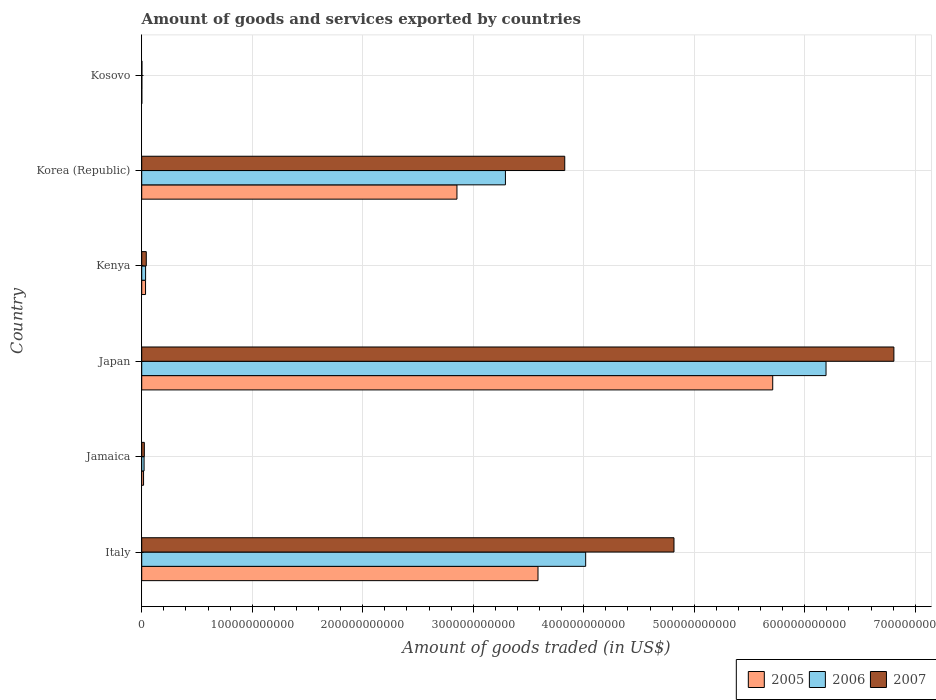How many groups of bars are there?
Give a very brief answer. 6. Are the number of bars on each tick of the Y-axis equal?
Your answer should be very brief. Yes. What is the label of the 1st group of bars from the top?
Ensure brevity in your answer.  Kosovo. In how many cases, is the number of bars for a given country not equal to the number of legend labels?
Provide a succinct answer. 0. What is the total amount of goods and services exported in 2006 in Italy?
Your response must be concise. 4.02e+11. Across all countries, what is the maximum total amount of goods and services exported in 2006?
Your answer should be compact. 6.19e+11. Across all countries, what is the minimum total amount of goods and services exported in 2007?
Give a very brief answer. 1.82e+08. In which country was the total amount of goods and services exported in 2005 minimum?
Offer a very short reply. Kosovo. What is the total total amount of goods and services exported in 2005 in the graph?
Ensure brevity in your answer.  1.22e+12. What is the difference between the total amount of goods and services exported in 2005 in Kenya and that in Korea (Republic)?
Offer a terse response. -2.82e+11. What is the difference between the total amount of goods and services exported in 2007 in Italy and the total amount of goods and services exported in 2006 in Jamaica?
Provide a succinct answer. 4.80e+11. What is the average total amount of goods and services exported in 2007 per country?
Provide a short and direct response. 2.59e+11. What is the difference between the total amount of goods and services exported in 2005 and total amount of goods and services exported in 2007 in Japan?
Your answer should be compact. -1.10e+11. What is the ratio of the total amount of goods and services exported in 2005 in Italy to that in Japan?
Ensure brevity in your answer.  0.63. Is the difference between the total amount of goods and services exported in 2005 in Japan and Korea (Republic) greater than the difference between the total amount of goods and services exported in 2007 in Japan and Korea (Republic)?
Make the answer very short. No. What is the difference between the highest and the second highest total amount of goods and services exported in 2005?
Your answer should be compact. 2.12e+11. What is the difference between the highest and the lowest total amount of goods and services exported in 2007?
Offer a terse response. 6.80e+11. In how many countries, is the total amount of goods and services exported in 2007 greater than the average total amount of goods and services exported in 2007 taken over all countries?
Provide a short and direct response. 3. Is the sum of the total amount of goods and services exported in 2007 in Italy and Japan greater than the maximum total amount of goods and services exported in 2006 across all countries?
Your answer should be very brief. Yes. What does the 1st bar from the top in Kosovo represents?
Make the answer very short. 2007. Is it the case that in every country, the sum of the total amount of goods and services exported in 2007 and total amount of goods and services exported in 2005 is greater than the total amount of goods and services exported in 2006?
Offer a terse response. Yes. How many bars are there?
Your answer should be very brief. 18. Are all the bars in the graph horizontal?
Offer a very short reply. Yes. How many countries are there in the graph?
Give a very brief answer. 6. What is the difference between two consecutive major ticks on the X-axis?
Your answer should be very brief. 1.00e+11. Are the values on the major ticks of X-axis written in scientific E-notation?
Provide a short and direct response. No. Does the graph contain any zero values?
Ensure brevity in your answer.  No. How are the legend labels stacked?
Ensure brevity in your answer.  Horizontal. What is the title of the graph?
Your answer should be compact. Amount of goods and services exported by countries. What is the label or title of the X-axis?
Your response must be concise. Amount of goods traded (in US$). What is the Amount of goods traded (in US$) of 2005 in Italy?
Offer a terse response. 3.59e+11. What is the Amount of goods traded (in US$) of 2006 in Italy?
Provide a succinct answer. 4.02e+11. What is the Amount of goods traded (in US$) in 2007 in Italy?
Make the answer very short. 4.82e+11. What is the Amount of goods traded (in US$) of 2005 in Jamaica?
Ensure brevity in your answer.  1.66e+09. What is the Amount of goods traded (in US$) in 2006 in Jamaica?
Make the answer very short. 2.13e+09. What is the Amount of goods traded (in US$) in 2007 in Jamaica?
Your answer should be compact. 2.36e+09. What is the Amount of goods traded (in US$) in 2005 in Japan?
Provide a succinct answer. 5.71e+11. What is the Amount of goods traded (in US$) of 2006 in Japan?
Offer a very short reply. 6.19e+11. What is the Amount of goods traded (in US$) of 2007 in Japan?
Give a very brief answer. 6.81e+11. What is the Amount of goods traded (in US$) of 2005 in Kenya?
Ensure brevity in your answer.  3.46e+09. What is the Amount of goods traded (in US$) in 2006 in Kenya?
Give a very brief answer. 3.51e+09. What is the Amount of goods traded (in US$) of 2007 in Kenya?
Keep it short and to the point. 4.12e+09. What is the Amount of goods traded (in US$) in 2005 in Korea (Republic)?
Your answer should be very brief. 2.85e+11. What is the Amount of goods traded (in US$) in 2006 in Korea (Republic)?
Your answer should be very brief. 3.29e+11. What is the Amount of goods traded (in US$) of 2007 in Korea (Republic)?
Keep it short and to the point. 3.83e+11. What is the Amount of goods traded (in US$) in 2005 in Kosovo?
Provide a short and direct response. 7.96e+07. What is the Amount of goods traded (in US$) of 2006 in Kosovo?
Keep it short and to the point. 1.24e+08. What is the Amount of goods traded (in US$) of 2007 in Kosovo?
Make the answer very short. 1.82e+08. Across all countries, what is the maximum Amount of goods traded (in US$) of 2005?
Offer a terse response. 5.71e+11. Across all countries, what is the maximum Amount of goods traded (in US$) in 2006?
Keep it short and to the point. 6.19e+11. Across all countries, what is the maximum Amount of goods traded (in US$) in 2007?
Make the answer very short. 6.81e+11. Across all countries, what is the minimum Amount of goods traded (in US$) of 2005?
Your answer should be very brief. 7.96e+07. Across all countries, what is the minimum Amount of goods traded (in US$) of 2006?
Offer a very short reply. 1.24e+08. Across all countries, what is the minimum Amount of goods traded (in US$) of 2007?
Give a very brief answer. 1.82e+08. What is the total Amount of goods traded (in US$) in 2005 in the graph?
Provide a succinct answer. 1.22e+12. What is the total Amount of goods traded (in US$) of 2006 in the graph?
Provide a succinct answer. 1.36e+12. What is the total Amount of goods traded (in US$) in 2007 in the graph?
Offer a very short reply. 1.55e+12. What is the difference between the Amount of goods traded (in US$) in 2005 in Italy and that in Jamaica?
Provide a succinct answer. 3.57e+11. What is the difference between the Amount of goods traded (in US$) of 2006 in Italy and that in Jamaica?
Make the answer very short. 4.00e+11. What is the difference between the Amount of goods traded (in US$) of 2007 in Italy and that in Jamaica?
Offer a terse response. 4.79e+11. What is the difference between the Amount of goods traded (in US$) in 2005 in Italy and that in Japan?
Your answer should be compact. -2.12e+11. What is the difference between the Amount of goods traded (in US$) in 2006 in Italy and that in Japan?
Make the answer very short. -2.18e+11. What is the difference between the Amount of goods traded (in US$) of 2007 in Italy and that in Japan?
Give a very brief answer. -1.99e+11. What is the difference between the Amount of goods traded (in US$) of 2005 in Italy and that in Kenya?
Your answer should be very brief. 3.55e+11. What is the difference between the Amount of goods traded (in US$) in 2006 in Italy and that in Kenya?
Your answer should be very brief. 3.98e+11. What is the difference between the Amount of goods traded (in US$) of 2007 in Italy and that in Kenya?
Provide a succinct answer. 4.78e+11. What is the difference between the Amount of goods traded (in US$) of 2005 in Italy and that in Korea (Republic)?
Offer a very short reply. 7.33e+1. What is the difference between the Amount of goods traded (in US$) in 2006 in Italy and that in Korea (Republic)?
Your answer should be very brief. 7.26e+1. What is the difference between the Amount of goods traded (in US$) of 2007 in Italy and that in Korea (Republic)?
Offer a very short reply. 9.88e+1. What is the difference between the Amount of goods traded (in US$) of 2005 in Italy and that in Kosovo?
Offer a terse response. 3.59e+11. What is the difference between the Amount of goods traded (in US$) in 2006 in Italy and that in Kosovo?
Ensure brevity in your answer.  4.02e+11. What is the difference between the Amount of goods traded (in US$) of 2007 in Italy and that in Kosovo?
Give a very brief answer. 4.81e+11. What is the difference between the Amount of goods traded (in US$) of 2005 in Jamaica and that in Japan?
Ensure brevity in your answer.  -5.69e+11. What is the difference between the Amount of goods traded (in US$) of 2006 in Jamaica and that in Japan?
Your answer should be compact. -6.17e+11. What is the difference between the Amount of goods traded (in US$) of 2007 in Jamaica and that in Japan?
Keep it short and to the point. -6.78e+11. What is the difference between the Amount of goods traded (in US$) of 2005 in Jamaica and that in Kenya?
Keep it short and to the point. -1.80e+09. What is the difference between the Amount of goods traded (in US$) of 2006 in Jamaica and that in Kenya?
Your answer should be compact. -1.38e+09. What is the difference between the Amount of goods traded (in US$) of 2007 in Jamaica and that in Kenya?
Provide a short and direct response. -1.76e+09. What is the difference between the Amount of goods traded (in US$) in 2005 in Jamaica and that in Korea (Republic)?
Keep it short and to the point. -2.84e+11. What is the difference between the Amount of goods traded (in US$) in 2006 in Jamaica and that in Korea (Republic)?
Provide a short and direct response. -3.27e+11. What is the difference between the Amount of goods traded (in US$) in 2007 in Jamaica and that in Korea (Republic)?
Ensure brevity in your answer.  -3.80e+11. What is the difference between the Amount of goods traded (in US$) of 2005 in Jamaica and that in Kosovo?
Your response must be concise. 1.58e+09. What is the difference between the Amount of goods traded (in US$) in 2006 in Jamaica and that in Kosovo?
Give a very brief answer. 2.01e+09. What is the difference between the Amount of goods traded (in US$) in 2007 in Jamaica and that in Kosovo?
Give a very brief answer. 2.18e+09. What is the difference between the Amount of goods traded (in US$) in 2005 in Japan and that in Kenya?
Offer a very short reply. 5.68e+11. What is the difference between the Amount of goods traded (in US$) of 2006 in Japan and that in Kenya?
Ensure brevity in your answer.  6.16e+11. What is the difference between the Amount of goods traded (in US$) of 2007 in Japan and that in Kenya?
Your response must be concise. 6.76e+11. What is the difference between the Amount of goods traded (in US$) of 2005 in Japan and that in Korea (Republic)?
Your answer should be compact. 2.86e+11. What is the difference between the Amount of goods traded (in US$) of 2006 in Japan and that in Korea (Republic)?
Provide a short and direct response. 2.90e+11. What is the difference between the Amount of goods traded (in US$) of 2007 in Japan and that in Korea (Republic)?
Provide a short and direct response. 2.98e+11. What is the difference between the Amount of goods traded (in US$) of 2005 in Japan and that in Kosovo?
Offer a terse response. 5.71e+11. What is the difference between the Amount of goods traded (in US$) in 2006 in Japan and that in Kosovo?
Provide a succinct answer. 6.19e+11. What is the difference between the Amount of goods traded (in US$) in 2007 in Japan and that in Kosovo?
Give a very brief answer. 6.80e+11. What is the difference between the Amount of goods traded (in US$) of 2005 in Kenya and that in Korea (Republic)?
Offer a terse response. -2.82e+11. What is the difference between the Amount of goods traded (in US$) in 2006 in Kenya and that in Korea (Republic)?
Ensure brevity in your answer.  -3.26e+11. What is the difference between the Amount of goods traded (in US$) in 2007 in Kenya and that in Korea (Republic)?
Ensure brevity in your answer.  -3.79e+11. What is the difference between the Amount of goods traded (in US$) in 2005 in Kenya and that in Kosovo?
Your response must be concise. 3.38e+09. What is the difference between the Amount of goods traded (in US$) of 2006 in Kenya and that in Kosovo?
Keep it short and to the point. 3.39e+09. What is the difference between the Amount of goods traded (in US$) of 2007 in Kenya and that in Kosovo?
Keep it short and to the point. 3.94e+09. What is the difference between the Amount of goods traded (in US$) in 2005 in Korea (Republic) and that in Kosovo?
Your answer should be compact. 2.85e+11. What is the difference between the Amount of goods traded (in US$) of 2006 in Korea (Republic) and that in Kosovo?
Your answer should be compact. 3.29e+11. What is the difference between the Amount of goods traded (in US$) in 2007 in Korea (Republic) and that in Kosovo?
Your answer should be compact. 3.83e+11. What is the difference between the Amount of goods traded (in US$) in 2005 in Italy and the Amount of goods traded (in US$) in 2006 in Jamaica?
Ensure brevity in your answer.  3.56e+11. What is the difference between the Amount of goods traded (in US$) in 2005 in Italy and the Amount of goods traded (in US$) in 2007 in Jamaica?
Your answer should be very brief. 3.56e+11. What is the difference between the Amount of goods traded (in US$) in 2006 in Italy and the Amount of goods traded (in US$) in 2007 in Jamaica?
Your response must be concise. 3.99e+11. What is the difference between the Amount of goods traded (in US$) in 2005 in Italy and the Amount of goods traded (in US$) in 2006 in Japan?
Give a very brief answer. -2.61e+11. What is the difference between the Amount of goods traded (in US$) in 2005 in Italy and the Amount of goods traded (in US$) in 2007 in Japan?
Your answer should be compact. -3.22e+11. What is the difference between the Amount of goods traded (in US$) in 2006 in Italy and the Amount of goods traded (in US$) in 2007 in Japan?
Your response must be concise. -2.79e+11. What is the difference between the Amount of goods traded (in US$) of 2005 in Italy and the Amount of goods traded (in US$) of 2006 in Kenya?
Your answer should be very brief. 3.55e+11. What is the difference between the Amount of goods traded (in US$) in 2005 in Italy and the Amount of goods traded (in US$) in 2007 in Kenya?
Make the answer very short. 3.54e+11. What is the difference between the Amount of goods traded (in US$) in 2006 in Italy and the Amount of goods traded (in US$) in 2007 in Kenya?
Keep it short and to the point. 3.98e+11. What is the difference between the Amount of goods traded (in US$) in 2005 in Italy and the Amount of goods traded (in US$) in 2006 in Korea (Republic)?
Your answer should be very brief. 2.95e+1. What is the difference between the Amount of goods traded (in US$) of 2005 in Italy and the Amount of goods traded (in US$) of 2007 in Korea (Republic)?
Give a very brief answer. -2.42e+1. What is the difference between the Amount of goods traded (in US$) in 2006 in Italy and the Amount of goods traded (in US$) in 2007 in Korea (Republic)?
Give a very brief answer. 1.89e+1. What is the difference between the Amount of goods traded (in US$) in 2005 in Italy and the Amount of goods traded (in US$) in 2006 in Kosovo?
Offer a very short reply. 3.58e+11. What is the difference between the Amount of goods traded (in US$) in 2005 in Italy and the Amount of goods traded (in US$) in 2007 in Kosovo?
Your answer should be compact. 3.58e+11. What is the difference between the Amount of goods traded (in US$) of 2006 in Italy and the Amount of goods traded (in US$) of 2007 in Kosovo?
Give a very brief answer. 4.02e+11. What is the difference between the Amount of goods traded (in US$) in 2005 in Jamaica and the Amount of goods traded (in US$) in 2006 in Japan?
Your answer should be compact. -6.18e+11. What is the difference between the Amount of goods traded (in US$) in 2005 in Jamaica and the Amount of goods traded (in US$) in 2007 in Japan?
Provide a succinct answer. -6.79e+11. What is the difference between the Amount of goods traded (in US$) of 2006 in Jamaica and the Amount of goods traded (in US$) of 2007 in Japan?
Offer a terse response. -6.78e+11. What is the difference between the Amount of goods traded (in US$) in 2005 in Jamaica and the Amount of goods traded (in US$) in 2006 in Kenya?
Offer a terse response. -1.84e+09. What is the difference between the Amount of goods traded (in US$) of 2005 in Jamaica and the Amount of goods traded (in US$) of 2007 in Kenya?
Ensure brevity in your answer.  -2.46e+09. What is the difference between the Amount of goods traded (in US$) in 2006 in Jamaica and the Amount of goods traded (in US$) in 2007 in Kenya?
Your answer should be very brief. -1.99e+09. What is the difference between the Amount of goods traded (in US$) in 2005 in Jamaica and the Amount of goods traded (in US$) in 2006 in Korea (Republic)?
Your response must be concise. -3.27e+11. What is the difference between the Amount of goods traded (in US$) of 2005 in Jamaica and the Amount of goods traded (in US$) of 2007 in Korea (Republic)?
Offer a very short reply. -3.81e+11. What is the difference between the Amount of goods traded (in US$) in 2006 in Jamaica and the Amount of goods traded (in US$) in 2007 in Korea (Republic)?
Give a very brief answer. -3.81e+11. What is the difference between the Amount of goods traded (in US$) of 2005 in Jamaica and the Amount of goods traded (in US$) of 2006 in Kosovo?
Make the answer very short. 1.54e+09. What is the difference between the Amount of goods traded (in US$) of 2005 in Jamaica and the Amount of goods traded (in US$) of 2007 in Kosovo?
Make the answer very short. 1.48e+09. What is the difference between the Amount of goods traded (in US$) in 2006 in Jamaica and the Amount of goods traded (in US$) in 2007 in Kosovo?
Your answer should be compact. 1.95e+09. What is the difference between the Amount of goods traded (in US$) in 2005 in Japan and the Amount of goods traded (in US$) in 2006 in Kenya?
Make the answer very short. 5.67e+11. What is the difference between the Amount of goods traded (in US$) of 2005 in Japan and the Amount of goods traded (in US$) of 2007 in Kenya?
Offer a very short reply. 5.67e+11. What is the difference between the Amount of goods traded (in US$) in 2006 in Japan and the Amount of goods traded (in US$) in 2007 in Kenya?
Offer a terse response. 6.15e+11. What is the difference between the Amount of goods traded (in US$) of 2005 in Japan and the Amount of goods traded (in US$) of 2006 in Korea (Republic)?
Keep it short and to the point. 2.42e+11. What is the difference between the Amount of goods traded (in US$) of 2005 in Japan and the Amount of goods traded (in US$) of 2007 in Korea (Republic)?
Provide a succinct answer. 1.88e+11. What is the difference between the Amount of goods traded (in US$) in 2006 in Japan and the Amount of goods traded (in US$) in 2007 in Korea (Republic)?
Give a very brief answer. 2.36e+11. What is the difference between the Amount of goods traded (in US$) in 2005 in Japan and the Amount of goods traded (in US$) in 2006 in Kosovo?
Keep it short and to the point. 5.71e+11. What is the difference between the Amount of goods traded (in US$) of 2005 in Japan and the Amount of goods traded (in US$) of 2007 in Kosovo?
Your answer should be very brief. 5.71e+11. What is the difference between the Amount of goods traded (in US$) of 2006 in Japan and the Amount of goods traded (in US$) of 2007 in Kosovo?
Your response must be concise. 6.19e+11. What is the difference between the Amount of goods traded (in US$) of 2005 in Kenya and the Amount of goods traded (in US$) of 2006 in Korea (Republic)?
Offer a terse response. -3.26e+11. What is the difference between the Amount of goods traded (in US$) in 2005 in Kenya and the Amount of goods traded (in US$) in 2007 in Korea (Republic)?
Your response must be concise. -3.79e+11. What is the difference between the Amount of goods traded (in US$) in 2006 in Kenya and the Amount of goods traded (in US$) in 2007 in Korea (Republic)?
Offer a very short reply. -3.79e+11. What is the difference between the Amount of goods traded (in US$) of 2005 in Kenya and the Amount of goods traded (in US$) of 2006 in Kosovo?
Offer a very short reply. 3.34e+09. What is the difference between the Amount of goods traded (in US$) in 2005 in Kenya and the Amount of goods traded (in US$) in 2007 in Kosovo?
Offer a terse response. 3.28e+09. What is the difference between the Amount of goods traded (in US$) in 2006 in Kenya and the Amount of goods traded (in US$) in 2007 in Kosovo?
Provide a short and direct response. 3.33e+09. What is the difference between the Amount of goods traded (in US$) in 2005 in Korea (Republic) and the Amount of goods traded (in US$) in 2006 in Kosovo?
Your response must be concise. 2.85e+11. What is the difference between the Amount of goods traded (in US$) of 2005 in Korea (Republic) and the Amount of goods traded (in US$) of 2007 in Kosovo?
Your answer should be compact. 2.85e+11. What is the difference between the Amount of goods traded (in US$) in 2006 in Korea (Republic) and the Amount of goods traded (in US$) in 2007 in Kosovo?
Provide a succinct answer. 3.29e+11. What is the average Amount of goods traded (in US$) in 2005 per country?
Offer a very short reply. 2.03e+11. What is the average Amount of goods traded (in US$) of 2006 per country?
Your answer should be very brief. 2.26e+11. What is the average Amount of goods traded (in US$) in 2007 per country?
Your answer should be compact. 2.59e+11. What is the difference between the Amount of goods traded (in US$) of 2005 and Amount of goods traded (in US$) of 2006 in Italy?
Keep it short and to the point. -4.31e+1. What is the difference between the Amount of goods traded (in US$) of 2005 and Amount of goods traded (in US$) of 2007 in Italy?
Your answer should be very brief. -1.23e+11. What is the difference between the Amount of goods traded (in US$) in 2006 and Amount of goods traded (in US$) in 2007 in Italy?
Make the answer very short. -7.99e+1. What is the difference between the Amount of goods traded (in US$) of 2005 and Amount of goods traded (in US$) of 2006 in Jamaica?
Ensure brevity in your answer.  -4.69e+08. What is the difference between the Amount of goods traded (in US$) in 2005 and Amount of goods traded (in US$) in 2007 in Jamaica?
Give a very brief answer. -6.98e+08. What is the difference between the Amount of goods traded (in US$) of 2006 and Amount of goods traded (in US$) of 2007 in Jamaica?
Your answer should be compact. -2.29e+08. What is the difference between the Amount of goods traded (in US$) in 2005 and Amount of goods traded (in US$) in 2006 in Japan?
Your answer should be very brief. -4.82e+1. What is the difference between the Amount of goods traded (in US$) in 2005 and Amount of goods traded (in US$) in 2007 in Japan?
Keep it short and to the point. -1.10e+11. What is the difference between the Amount of goods traded (in US$) in 2006 and Amount of goods traded (in US$) in 2007 in Japan?
Offer a very short reply. -6.14e+1. What is the difference between the Amount of goods traded (in US$) of 2005 and Amount of goods traded (in US$) of 2006 in Kenya?
Your answer should be very brief. -4.95e+07. What is the difference between the Amount of goods traded (in US$) of 2005 and Amount of goods traded (in US$) of 2007 in Kenya?
Make the answer very short. -6.64e+08. What is the difference between the Amount of goods traded (in US$) in 2006 and Amount of goods traded (in US$) in 2007 in Kenya?
Give a very brief answer. -6.14e+08. What is the difference between the Amount of goods traded (in US$) in 2005 and Amount of goods traded (in US$) in 2006 in Korea (Republic)?
Give a very brief answer. -4.38e+1. What is the difference between the Amount of goods traded (in US$) of 2005 and Amount of goods traded (in US$) of 2007 in Korea (Republic)?
Your response must be concise. -9.75e+1. What is the difference between the Amount of goods traded (in US$) of 2006 and Amount of goods traded (in US$) of 2007 in Korea (Republic)?
Your answer should be compact. -5.37e+1. What is the difference between the Amount of goods traded (in US$) of 2005 and Amount of goods traded (in US$) of 2006 in Kosovo?
Provide a short and direct response. -4.40e+07. What is the difference between the Amount of goods traded (in US$) of 2005 and Amount of goods traded (in US$) of 2007 in Kosovo?
Give a very brief answer. -1.02e+08. What is the difference between the Amount of goods traded (in US$) of 2006 and Amount of goods traded (in US$) of 2007 in Kosovo?
Your answer should be very brief. -5.80e+07. What is the ratio of the Amount of goods traded (in US$) of 2005 in Italy to that in Jamaica?
Ensure brevity in your answer.  215.46. What is the ratio of the Amount of goods traded (in US$) of 2006 in Italy to that in Jamaica?
Your answer should be compact. 188.28. What is the ratio of the Amount of goods traded (in US$) of 2007 in Italy to that in Jamaica?
Give a very brief answer. 203.86. What is the ratio of the Amount of goods traded (in US$) of 2005 in Italy to that in Japan?
Provide a succinct answer. 0.63. What is the ratio of the Amount of goods traded (in US$) of 2006 in Italy to that in Japan?
Offer a terse response. 0.65. What is the ratio of the Amount of goods traded (in US$) of 2007 in Italy to that in Japan?
Offer a very short reply. 0.71. What is the ratio of the Amount of goods traded (in US$) in 2005 in Italy to that in Kenya?
Your answer should be very brief. 103.66. What is the ratio of the Amount of goods traded (in US$) of 2006 in Italy to that in Kenya?
Provide a succinct answer. 114.48. What is the ratio of the Amount of goods traded (in US$) in 2007 in Italy to that in Kenya?
Provide a succinct answer. 116.81. What is the ratio of the Amount of goods traded (in US$) in 2005 in Italy to that in Korea (Republic)?
Your response must be concise. 1.26. What is the ratio of the Amount of goods traded (in US$) in 2006 in Italy to that in Korea (Republic)?
Provide a succinct answer. 1.22. What is the ratio of the Amount of goods traded (in US$) in 2007 in Italy to that in Korea (Republic)?
Offer a very short reply. 1.26. What is the ratio of the Amount of goods traded (in US$) of 2005 in Italy to that in Kosovo?
Make the answer very short. 4503.54. What is the ratio of the Amount of goods traded (in US$) of 2006 in Italy to that in Kosovo?
Offer a terse response. 3250.28. What is the ratio of the Amount of goods traded (in US$) of 2007 in Italy to that in Kosovo?
Keep it short and to the point. 2652.91. What is the ratio of the Amount of goods traded (in US$) in 2005 in Jamaica to that in Japan?
Provide a short and direct response. 0. What is the ratio of the Amount of goods traded (in US$) in 2006 in Jamaica to that in Japan?
Keep it short and to the point. 0. What is the ratio of the Amount of goods traded (in US$) of 2007 in Jamaica to that in Japan?
Offer a terse response. 0. What is the ratio of the Amount of goods traded (in US$) in 2005 in Jamaica to that in Kenya?
Offer a terse response. 0.48. What is the ratio of the Amount of goods traded (in US$) of 2006 in Jamaica to that in Kenya?
Make the answer very short. 0.61. What is the ratio of the Amount of goods traded (in US$) of 2007 in Jamaica to that in Kenya?
Offer a very short reply. 0.57. What is the ratio of the Amount of goods traded (in US$) of 2005 in Jamaica to that in Korea (Republic)?
Your answer should be very brief. 0.01. What is the ratio of the Amount of goods traded (in US$) of 2006 in Jamaica to that in Korea (Republic)?
Provide a short and direct response. 0.01. What is the ratio of the Amount of goods traded (in US$) of 2007 in Jamaica to that in Korea (Republic)?
Provide a short and direct response. 0.01. What is the ratio of the Amount of goods traded (in US$) in 2005 in Jamaica to that in Kosovo?
Give a very brief answer. 20.9. What is the ratio of the Amount of goods traded (in US$) in 2006 in Jamaica to that in Kosovo?
Offer a terse response. 17.26. What is the ratio of the Amount of goods traded (in US$) in 2007 in Jamaica to that in Kosovo?
Offer a terse response. 13.01. What is the ratio of the Amount of goods traded (in US$) of 2005 in Japan to that in Kenya?
Provide a short and direct response. 165.05. What is the ratio of the Amount of goods traded (in US$) of 2006 in Japan to that in Kenya?
Your answer should be compact. 176.47. What is the ratio of the Amount of goods traded (in US$) of 2007 in Japan to that in Kenya?
Offer a terse response. 165.07. What is the ratio of the Amount of goods traded (in US$) in 2005 in Japan to that in Korea (Republic)?
Keep it short and to the point. 2. What is the ratio of the Amount of goods traded (in US$) in 2006 in Japan to that in Korea (Republic)?
Keep it short and to the point. 1.88. What is the ratio of the Amount of goods traded (in US$) of 2007 in Japan to that in Korea (Republic)?
Provide a succinct answer. 1.78. What is the ratio of the Amount of goods traded (in US$) of 2005 in Japan to that in Kosovo?
Your answer should be very brief. 7170.93. What is the ratio of the Amount of goods traded (in US$) of 2006 in Japan to that in Kosovo?
Make the answer very short. 5010.07. What is the ratio of the Amount of goods traded (in US$) of 2007 in Japan to that in Kosovo?
Your answer should be compact. 3748.94. What is the ratio of the Amount of goods traded (in US$) in 2005 in Kenya to that in Korea (Republic)?
Offer a terse response. 0.01. What is the ratio of the Amount of goods traded (in US$) in 2006 in Kenya to that in Korea (Republic)?
Keep it short and to the point. 0.01. What is the ratio of the Amount of goods traded (in US$) in 2007 in Kenya to that in Korea (Republic)?
Offer a very short reply. 0.01. What is the ratio of the Amount of goods traded (in US$) of 2005 in Kenya to that in Kosovo?
Provide a succinct answer. 43.45. What is the ratio of the Amount of goods traded (in US$) of 2006 in Kenya to that in Kosovo?
Your answer should be compact. 28.39. What is the ratio of the Amount of goods traded (in US$) in 2007 in Kenya to that in Kosovo?
Ensure brevity in your answer.  22.71. What is the ratio of the Amount of goods traded (in US$) in 2005 in Korea (Republic) to that in Kosovo?
Offer a very short reply. 3582.49. What is the ratio of the Amount of goods traded (in US$) of 2006 in Korea (Republic) to that in Kosovo?
Provide a succinct answer. 2662.76. What is the ratio of the Amount of goods traded (in US$) of 2007 in Korea (Republic) to that in Kosovo?
Keep it short and to the point. 2108.44. What is the difference between the highest and the second highest Amount of goods traded (in US$) in 2005?
Make the answer very short. 2.12e+11. What is the difference between the highest and the second highest Amount of goods traded (in US$) of 2006?
Offer a terse response. 2.18e+11. What is the difference between the highest and the second highest Amount of goods traded (in US$) of 2007?
Your response must be concise. 1.99e+11. What is the difference between the highest and the lowest Amount of goods traded (in US$) in 2005?
Your response must be concise. 5.71e+11. What is the difference between the highest and the lowest Amount of goods traded (in US$) in 2006?
Provide a short and direct response. 6.19e+11. What is the difference between the highest and the lowest Amount of goods traded (in US$) in 2007?
Provide a succinct answer. 6.80e+11. 